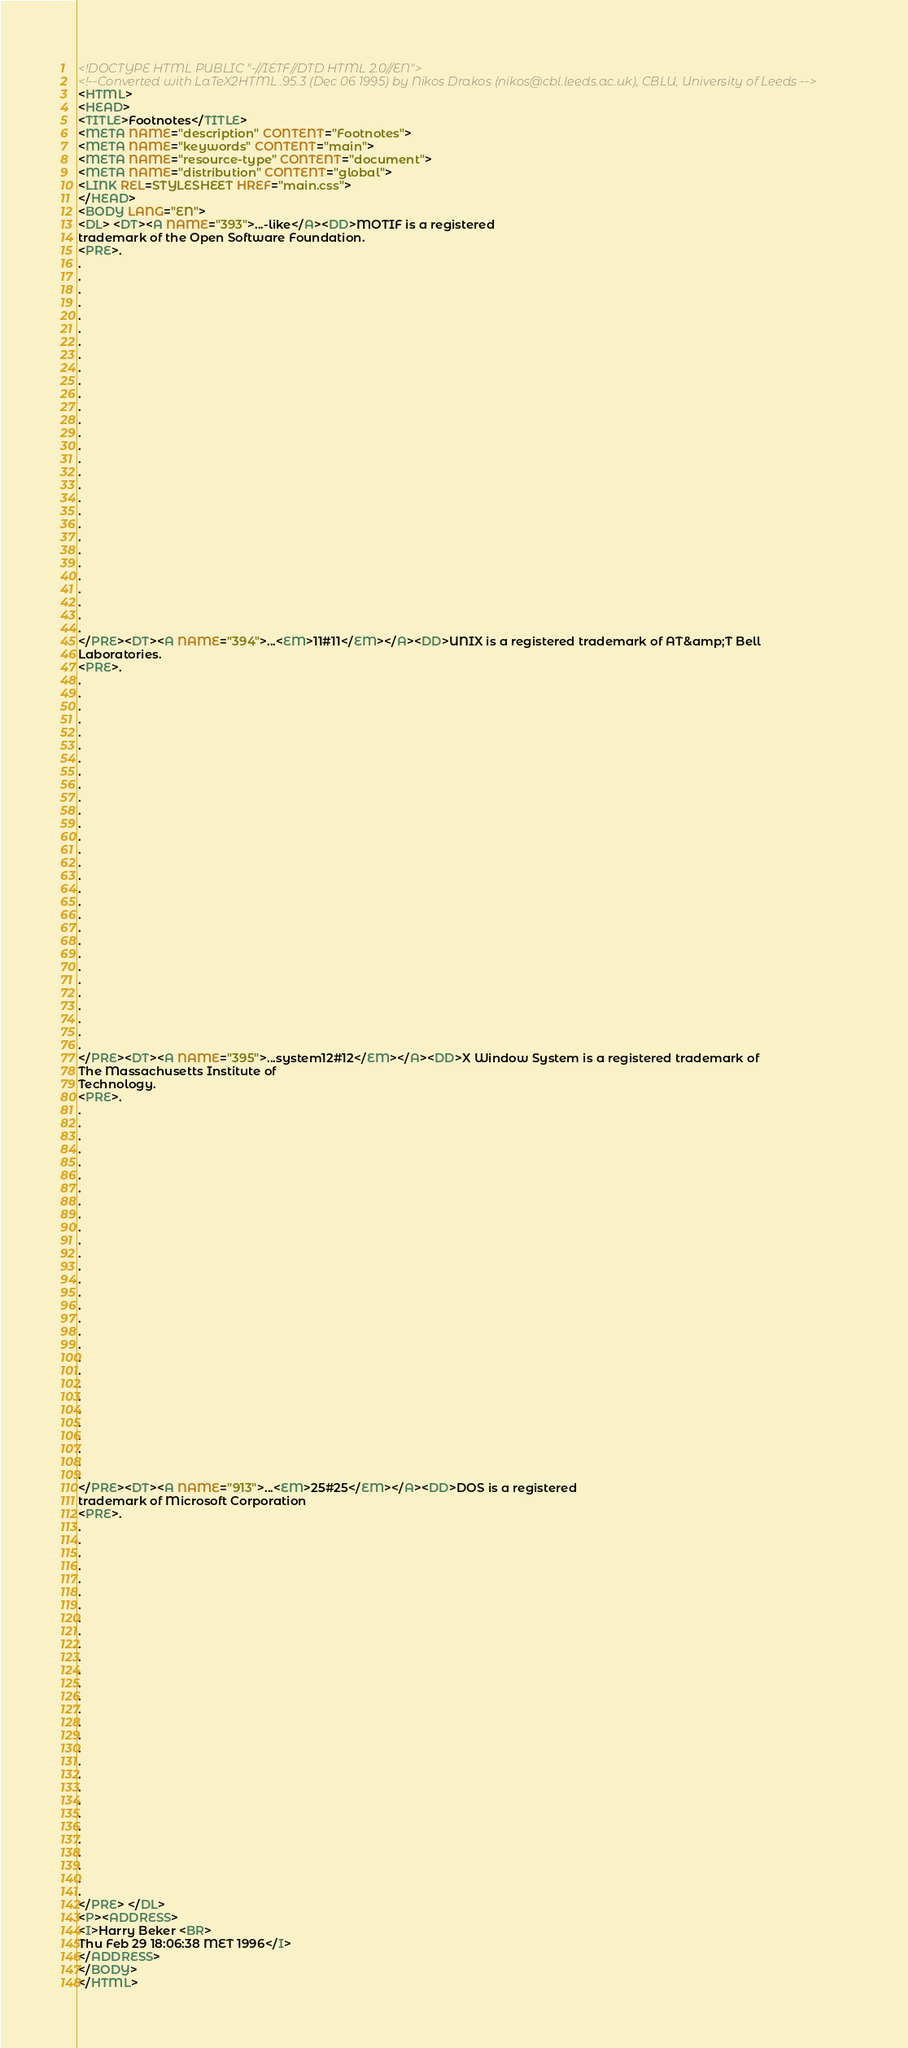Convert code to text. <code><loc_0><loc_0><loc_500><loc_500><_HTML_><!DOCTYPE HTML PUBLIC "-//IETF//DTD HTML 2.0//EN">
<!--Converted with LaTeX2HTML .95.3 (Dec 06 1995) by Nikos Drakos (nikos@cbl.leeds.ac.uk), CBLU, University of Leeds -->
<HTML>
<HEAD>
<TITLE>Footnotes</TITLE>
<META NAME="description" CONTENT="Footnotes">
<META NAME="keywords" CONTENT="main">
<META NAME="resource-type" CONTENT="document">
<META NAME="distribution" CONTENT="global">
<LINK REL=STYLESHEET HREF="main.css">
</HEAD>
<BODY LANG="EN">
<DL> <DT><A NAME="393">...-like</A><DD>MOTIF is a registered
trademark of the Open Software Foundation.
<PRE>.
.
.
.
.
.
.
.
.
.
.
.
.
.
.
.
.
.
.
.
.
.
.
.
.
.
.
.
.
.
</PRE><DT><A NAME="394">...<EM>11#11</EM></A><DD>UNIX is a registered trademark of AT&amp;T Bell
Laboratories.
<PRE>.
.
.
.
.
.
.
.
.
.
.
.
.
.
.
.
.
.
.
.
.
.
.
.
.
.
.
.
.
.
</PRE><DT><A NAME="395">...system12#12</EM></A><DD>X Window System is a registered trademark of
The Massachusetts Institute of
Technology.
<PRE>.
.
.
.
.
.
.
.
.
.
.
.
.
.
.
.
.
.
.
.
.
.
.
.
.
.
.
.
.
.
</PRE><DT><A NAME="913">...<EM>25#25</EM></A><DD>DOS is a registered
trademark of Microsoft Corporation
<PRE>.
.
.
.
.
.
.
.
.
.
.
.
.
.
.
.
.
.
.
.
.
.
.
.
.
.
.
.
.
.
</PRE> </DL>
<P><ADDRESS>
<I>Harry Beker <BR>
Thu Feb 29 18:06:38 MET 1996</I>
</ADDRESS>
</BODY>
</HTML>
</code> 